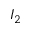Convert formula to latex. <formula><loc_0><loc_0><loc_500><loc_500>I _ { 2 }</formula> 